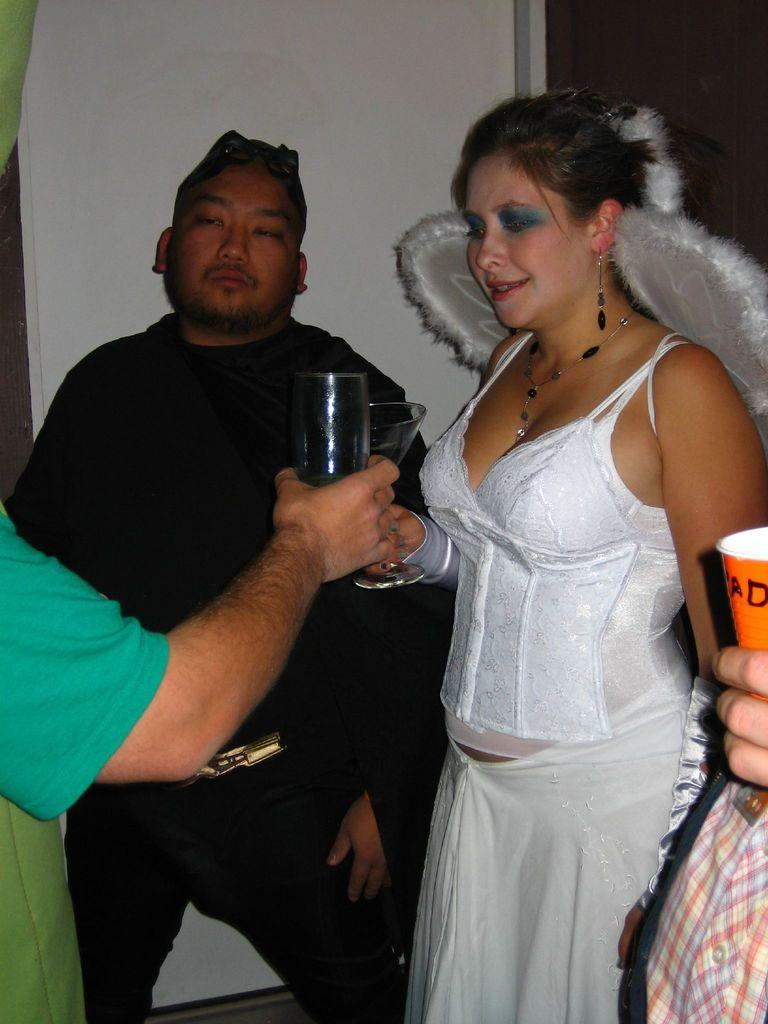How many people are in the image? There are people in the image, but the exact number is not specified. What are the people doing in the image? The people are standing in the image. What objects are the people holding in the image? The people are holding glasses in the image. What can be seen in the background of the image? There is a wall in the background of the image. What type of shoe can be seen on the people's feet in the image? There is no mention of shoes or any footwear in the image. What sound do the bells make in the image? There is no mention of bells or any sound-making objects in the image. Are there any dinosaurs visible in the image? There is no mention of dinosaurs or any prehistoric creatures in the image. 